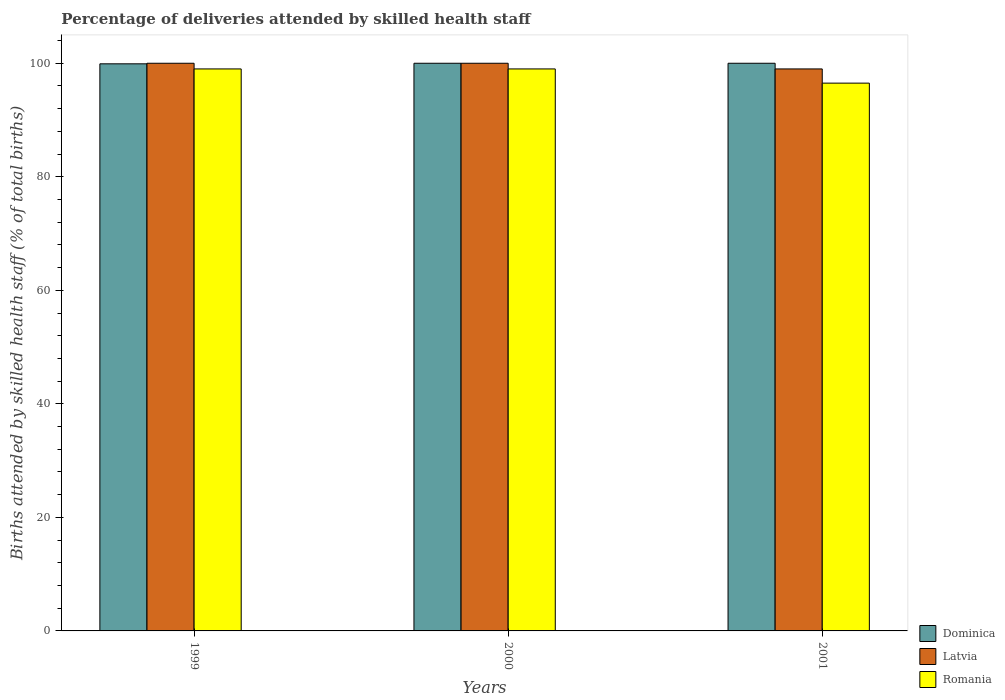How many groups of bars are there?
Give a very brief answer. 3. Are the number of bars per tick equal to the number of legend labels?
Offer a terse response. Yes. How many bars are there on the 1st tick from the right?
Make the answer very short. 3. What is the label of the 1st group of bars from the left?
Your answer should be compact. 1999. In how many cases, is the number of bars for a given year not equal to the number of legend labels?
Make the answer very short. 0. What is the percentage of births attended by skilled health staff in Romania in 2000?
Provide a succinct answer. 99. Across all years, what is the maximum percentage of births attended by skilled health staff in Latvia?
Offer a very short reply. 100. In which year was the percentage of births attended by skilled health staff in Latvia minimum?
Offer a very short reply. 2001. What is the total percentage of births attended by skilled health staff in Romania in the graph?
Ensure brevity in your answer.  294.5. What is the difference between the percentage of births attended by skilled health staff in Romania in 1999 and that in 2000?
Your answer should be compact. 0. What is the difference between the percentage of births attended by skilled health staff in Romania in 2001 and the percentage of births attended by skilled health staff in Dominica in 1999?
Make the answer very short. -3.4. What is the average percentage of births attended by skilled health staff in Latvia per year?
Ensure brevity in your answer.  99.67. In the year 1999, what is the difference between the percentage of births attended by skilled health staff in Dominica and percentage of births attended by skilled health staff in Latvia?
Provide a short and direct response. -0.1. In how many years, is the percentage of births attended by skilled health staff in Dominica greater than 48 %?
Offer a terse response. 3. Is the percentage of births attended by skilled health staff in Romania in 1999 less than that in 2000?
Offer a very short reply. No. Is the difference between the percentage of births attended by skilled health staff in Dominica in 1999 and 2000 greater than the difference between the percentage of births attended by skilled health staff in Latvia in 1999 and 2000?
Provide a short and direct response. No. What is the difference between the highest and the second highest percentage of births attended by skilled health staff in Latvia?
Your answer should be very brief. 0. What is the difference between the highest and the lowest percentage of births attended by skilled health staff in Latvia?
Your response must be concise. 1. What does the 2nd bar from the left in 2000 represents?
Offer a very short reply. Latvia. What does the 1st bar from the right in 1999 represents?
Your answer should be compact. Romania. Are all the bars in the graph horizontal?
Provide a short and direct response. No. What is the difference between two consecutive major ticks on the Y-axis?
Keep it short and to the point. 20. Does the graph contain any zero values?
Give a very brief answer. No. Where does the legend appear in the graph?
Your response must be concise. Bottom right. What is the title of the graph?
Offer a terse response. Percentage of deliveries attended by skilled health staff. What is the label or title of the X-axis?
Your response must be concise. Years. What is the label or title of the Y-axis?
Provide a short and direct response. Births attended by skilled health staff (% of total births). What is the Births attended by skilled health staff (% of total births) of Dominica in 1999?
Give a very brief answer. 99.9. What is the Births attended by skilled health staff (% of total births) in Latvia in 2000?
Offer a terse response. 100. What is the Births attended by skilled health staff (% of total births) of Dominica in 2001?
Your response must be concise. 100. What is the Births attended by skilled health staff (% of total births) of Romania in 2001?
Offer a terse response. 96.5. Across all years, what is the maximum Births attended by skilled health staff (% of total births) of Dominica?
Keep it short and to the point. 100. Across all years, what is the maximum Births attended by skilled health staff (% of total births) in Romania?
Offer a very short reply. 99. Across all years, what is the minimum Births attended by skilled health staff (% of total births) in Dominica?
Give a very brief answer. 99.9. Across all years, what is the minimum Births attended by skilled health staff (% of total births) in Romania?
Ensure brevity in your answer.  96.5. What is the total Births attended by skilled health staff (% of total births) of Dominica in the graph?
Offer a terse response. 299.9. What is the total Births attended by skilled health staff (% of total births) in Latvia in the graph?
Your answer should be very brief. 299. What is the total Births attended by skilled health staff (% of total births) in Romania in the graph?
Provide a succinct answer. 294.5. What is the difference between the Births attended by skilled health staff (% of total births) of Romania in 1999 and that in 2000?
Keep it short and to the point. 0. What is the difference between the Births attended by skilled health staff (% of total births) in Dominica in 1999 and that in 2001?
Your response must be concise. -0.1. What is the difference between the Births attended by skilled health staff (% of total births) of Latvia in 1999 and that in 2001?
Offer a very short reply. 1. What is the difference between the Births attended by skilled health staff (% of total births) in Romania in 1999 and that in 2001?
Give a very brief answer. 2.5. What is the difference between the Births attended by skilled health staff (% of total births) in Dominica in 2000 and that in 2001?
Offer a terse response. 0. What is the difference between the Births attended by skilled health staff (% of total births) in Dominica in 1999 and the Births attended by skilled health staff (% of total births) in Latvia in 2000?
Offer a terse response. -0.1. What is the difference between the Births attended by skilled health staff (% of total births) of Latvia in 1999 and the Births attended by skilled health staff (% of total births) of Romania in 2000?
Your response must be concise. 1. What is the difference between the Births attended by skilled health staff (% of total births) in Dominica in 1999 and the Births attended by skilled health staff (% of total births) in Romania in 2001?
Offer a very short reply. 3.4. What is the difference between the Births attended by skilled health staff (% of total births) in Dominica in 2000 and the Births attended by skilled health staff (% of total births) in Latvia in 2001?
Keep it short and to the point. 1. What is the difference between the Births attended by skilled health staff (% of total births) in Dominica in 2000 and the Births attended by skilled health staff (% of total births) in Romania in 2001?
Your answer should be very brief. 3.5. What is the average Births attended by skilled health staff (% of total births) in Dominica per year?
Provide a short and direct response. 99.97. What is the average Births attended by skilled health staff (% of total births) in Latvia per year?
Keep it short and to the point. 99.67. What is the average Births attended by skilled health staff (% of total births) of Romania per year?
Your answer should be compact. 98.17. In the year 1999, what is the difference between the Births attended by skilled health staff (% of total births) in Dominica and Births attended by skilled health staff (% of total births) in Romania?
Provide a short and direct response. 0.9. In the year 2000, what is the difference between the Births attended by skilled health staff (% of total births) in Dominica and Births attended by skilled health staff (% of total births) in Latvia?
Make the answer very short. 0. In the year 2000, what is the difference between the Births attended by skilled health staff (% of total births) in Dominica and Births attended by skilled health staff (% of total births) in Romania?
Make the answer very short. 1. In the year 2001, what is the difference between the Births attended by skilled health staff (% of total births) in Dominica and Births attended by skilled health staff (% of total births) in Romania?
Make the answer very short. 3.5. In the year 2001, what is the difference between the Births attended by skilled health staff (% of total births) in Latvia and Births attended by skilled health staff (% of total births) in Romania?
Your answer should be very brief. 2.5. What is the ratio of the Births attended by skilled health staff (% of total births) in Dominica in 1999 to that in 2000?
Your answer should be compact. 1. What is the ratio of the Births attended by skilled health staff (% of total births) in Latvia in 1999 to that in 2000?
Provide a short and direct response. 1. What is the ratio of the Births attended by skilled health staff (% of total births) of Romania in 1999 to that in 2000?
Offer a very short reply. 1. What is the ratio of the Births attended by skilled health staff (% of total births) of Dominica in 1999 to that in 2001?
Provide a short and direct response. 1. What is the ratio of the Births attended by skilled health staff (% of total births) in Latvia in 1999 to that in 2001?
Provide a succinct answer. 1.01. What is the ratio of the Births attended by skilled health staff (% of total births) of Romania in 1999 to that in 2001?
Give a very brief answer. 1.03. What is the ratio of the Births attended by skilled health staff (% of total births) of Dominica in 2000 to that in 2001?
Give a very brief answer. 1. What is the ratio of the Births attended by skilled health staff (% of total births) of Romania in 2000 to that in 2001?
Ensure brevity in your answer.  1.03. What is the difference between the highest and the second highest Births attended by skilled health staff (% of total births) in Latvia?
Offer a terse response. 0. What is the difference between the highest and the lowest Births attended by skilled health staff (% of total births) of Latvia?
Your answer should be very brief. 1. 